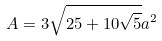Convert formula to latex. <formula><loc_0><loc_0><loc_500><loc_500>A = 3 \sqrt { 2 5 + 1 0 \sqrt { 5 } } a ^ { 2 }</formula> 